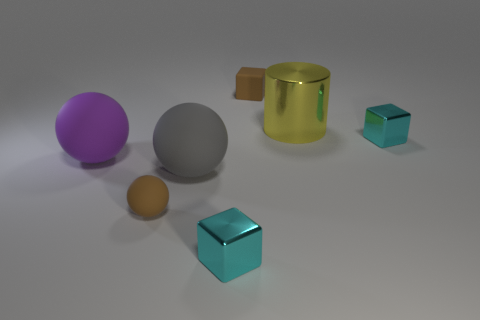Subtract all cyan blocks. How many blocks are left? 1 Subtract all cyan balls. How many cyan blocks are left? 2 Subtract 1 spheres. How many spheres are left? 2 Subtract all purple balls. How many balls are left? 2 Add 3 big purple blocks. How many objects exist? 10 Subtract all red spheres. Subtract all yellow blocks. How many spheres are left? 3 Subtract all cubes. How many objects are left? 4 Subtract all purple cubes. Subtract all large purple rubber things. How many objects are left? 6 Add 2 large gray matte balls. How many large gray matte balls are left? 3 Add 7 tiny brown rubber cubes. How many tiny brown rubber cubes exist? 8 